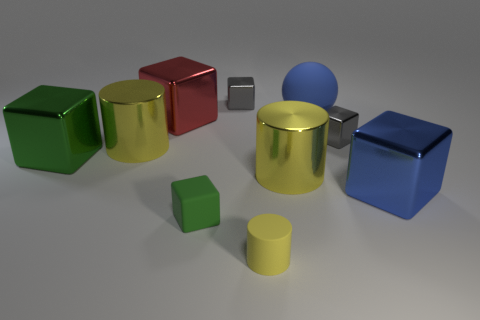Subtract all red blocks. How many blocks are left? 5 Subtract 2 blocks. How many blocks are left? 4 Subtract all rubber cubes. How many cubes are left? 5 Subtract all yellow blocks. Subtract all cyan spheres. How many blocks are left? 6 Subtract all balls. How many objects are left? 9 Add 2 tiny gray blocks. How many tiny gray blocks exist? 4 Subtract 0 purple cylinders. How many objects are left? 10 Subtract all green rubber cubes. Subtract all blue shiny blocks. How many objects are left? 8 Add 9 red objects. How many red objects are left? 10 